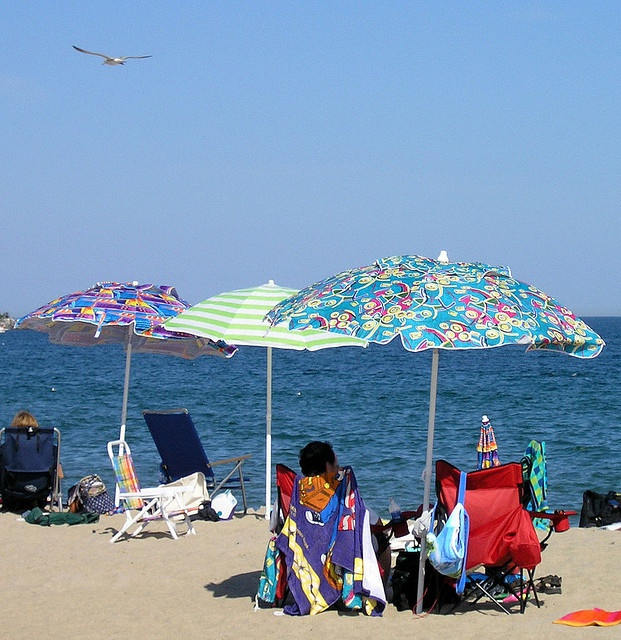Describe the objects in this image and their specific colors. I can see umbrella in lightblue, ivory, and darkgray tones, chair in lightblue, black, brown, and salmon tones, umbrella in lightblue, gray, lavender, and darkgray tones, chair in lightblue, white, gray, darkgray, and tan tones, and umbrella in lightblue, white, lightgreen, and darkgray tones in this image. 